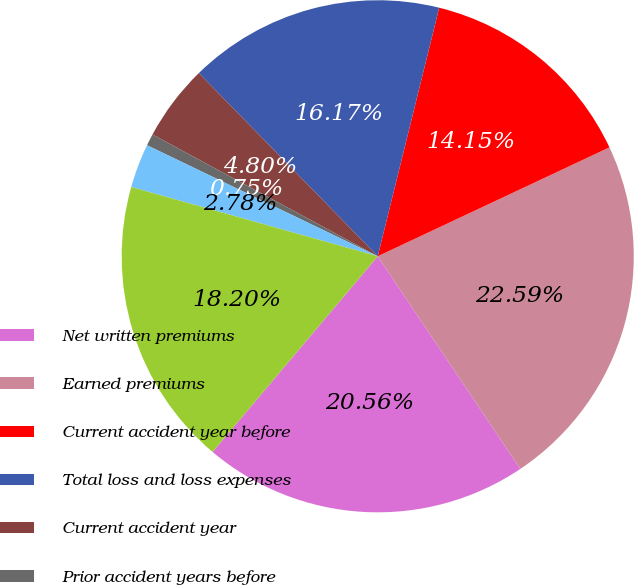<chart> <loc_0><loc_0><loc_500><loc_500><pie_chart><fcel>Net written premiums<fcel>Earned premiums<fcel>Current accident year before<fcel>Total loss and loss expenses<fcel>Current accident year<fcel>Prior accident years before<fcel>Prior accident years<fcel>Total loss and loss expense<nl><fcel>20.56%<fcel>22.59%<fcel>14.15%<fcel>16.17%<fcel>4.8%<fcel>0.75%<fcel>2.78%<fcel>18.2%<nl></chart> 